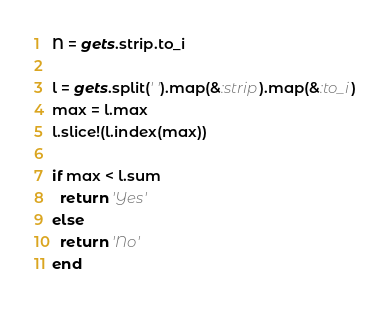<code> <loc_0><loc_0><loc_500><loc_500><_Ruby_>N = gets.strip.to_i

l = gets.split(' ').map(&:strip).map(&:to_i)
max = l.max
l.slice!(l.index(max))

if max < l.sum
  return 'Yes'
else 
  return 'No'
end </code> 